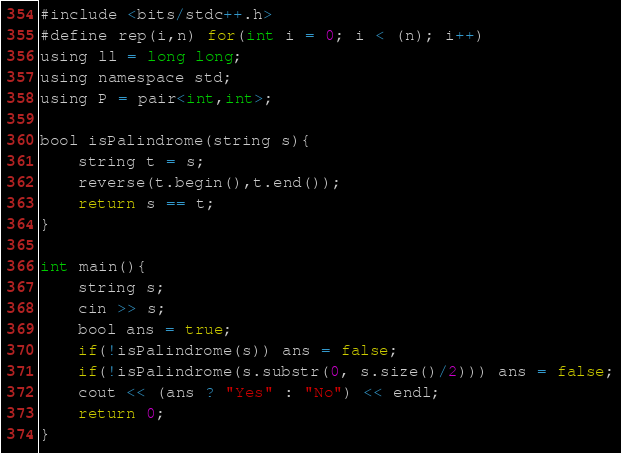<code> <loc_0><loc_0><loc_500><loc_500><_Java_>#include <bits/stdc++.h>
#define rep(i,n) for(int i = 0; i < (n); i++)
using ll = long long;
using namespace std;
using P = pair<int,int>;

bool isPalindrome(string s){
    string t = s;
    reverse(t.begin(),t.end());
    return s == t;
}

int main(){
    string s;
    cin >> s;
    bool ans = true;
    if(!isPalindrome(s)) ans = false;
    if(!isPalindrome(s.substr(0, s.size()/2))) ans = false;
    cout << (ans ? "Yes" : "No") << endl;
    return 0;
}</code> 